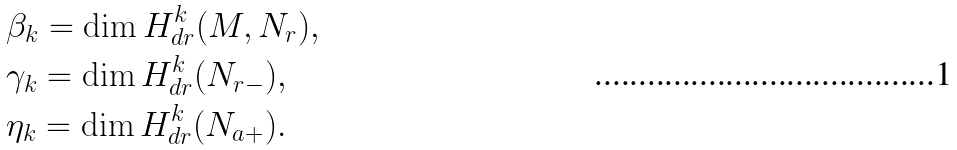<formula> <loc_0><loc_0><loc_500><loc_500>& \beta _ { k } = \dim H ^ { k } _ { d r } ( M , N _ { r } ) , \\ & \gamma _ { k } = \dim H ^ { k } _ { d r } ( N _ { r - } ) , \\ & \eta _ { k } = \dim H ^ { k } _ { d r } ( N _ { a + } ) .</formula> 